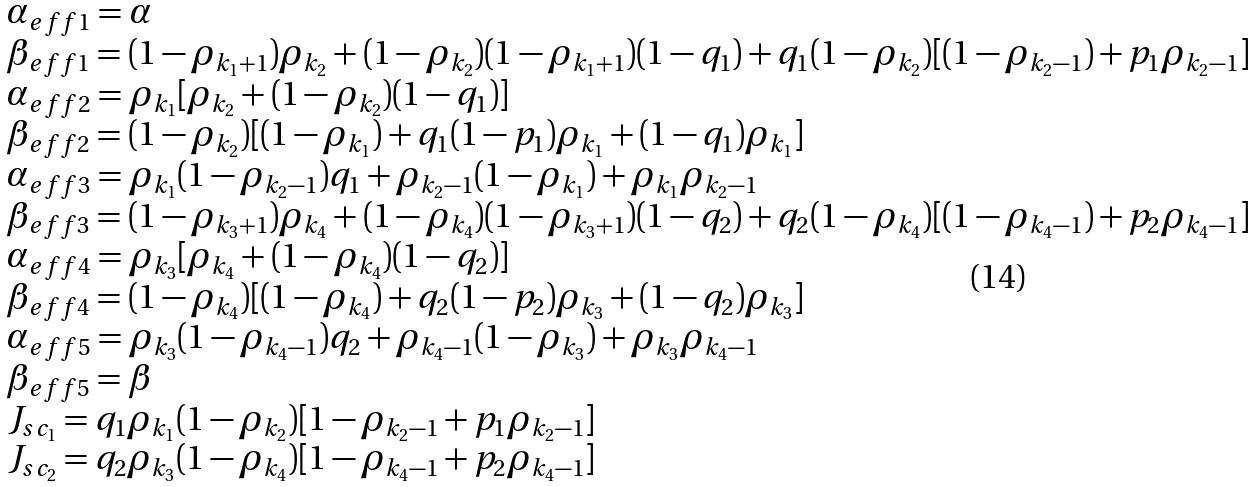Convert formula to latex. <formula><loc_0><loc_0><loc_500><loc_500>\begin{array} { l } \alpha _ { e f f 1 } = \alpha \\ \beta _ { e f f 1 } = ( 1 - \rho _ { k _ { 1 } + 1 } ) \rho _ { k _ { 2 } } + ( 1 - \rho _ { k _ { 2 } } ) ( 1 - \rho _ { k _ { 1 } + 1 } ) ( 1 - q _ { 1 } ) + q _ { 1 } ( 1 - \rho _ { k _ { 2 } } ) [ ( 1 - \rho _ { k _ { 2 } - 1 } ) + p _ { 1 } \rho _ { k _ { 2 } - 1 } ] \\ \alpha _ { e f f 2 } = \rho _ { k _ { 1 } } [ \rho _ { k _ { 2 } } + ( 1 - \rho _ { k _ { 2 } } ) ( 1 - q _ { 1 } ) ] \\ \beta _ { e f f 2 } = ( 1 - \rho _ { k _ { 2 } } ) [ ( 1 - \rho _ { k _ { 1 } } ) + q _ { 1 } ( 1 - p _ { 1 } ) \rho _ { k _ { 1 } } + ( 1 - q _ { 1 } ) \rho _ { k _ { 1 } } ] \\ \alpha _ { e f f 3 } = \rho _ { k _ { 1 } } ( 1 - \rho _ { k _ { 2 } - 1 } ) q _ { 1 } + \rho _ { k _ { 2 } - 1 } ( 1 - \rho _ { k _ { 1 } } ) + \rho _ { k _ { 1 } } \rho _ { k _ { 2 } - 1 } \\ \beta _ { e f f 3 } = ( 1 - \rho _ { k _ { 3 } + 1 } ) \rho _ { k _ { 4 } } + ( 1 - \rho _ { k _ { 4 } } ) ( 1 - \rho _ { k _ { 3 } + 1 } ) ( 1 - q _ { 2 } ) + q _ { 2 } ( 1 - \rho _ { k _ { 4 } } ) [ ( 1 - \rho _ { k _ { 4 } - 1 } ) + p _ { 2 } \rho _ { k _ { 4 } - 1 } ] \\ \alpha _ { e f f 4 } = \rho _ { k _ { 3 } } [ \rho _ { k _ { 4 } } + ( 1 - \rho _ { k _ { 4 } } ) ( 1 - q _ { 2 } ) ] \\ \beta _ { e f f 4 } = ( 1 - \rho _ { k _ { 4 } } ) [ ( 1 - \rho _ { k _ { 4 } } ) + q _ { 2 } ( 1 - p _ { 2 } ) \rho _ { k _ { 3 } } + ( 1 - q _ { 2 } ) \rho _ { k _ { 3 } } ] \\ \alpha _ { e f f 5 } = \rho _ { k _ { 3 } } ( 1 - \rho _ { k _ { 4 } - 1 } ) q _ { 2 } + \rho _ { k _ { 4 } - 1 } ( 1 - \rho _ { k _ { 3 } } ) + \rho _ { k _ { 3 } } \rho _ { k _ { 4 } - 1 } \\ \beta _ { e f f 5 } = \beta \\ J _ { s c _ { 1 } } = q _ { 1 } \rho _ { k _ { 1 } } ( 1 - \rho _ { k _ { 2 } } ) [ 1 - \rho _ { k _ { 2 } - 1 } + p _ { 1 } \rho _ { k _ { 2 } - 1 } ] \\ J _ { s c _ { 2 } } = q _ { 2 } \rho _ { k _ { 3 } } ( 1 - \rho _ { k _ { 4 } } ) [ 1 - \rho _ { k _ { 4 } - 1 } + p _ { 2 } \rho _ { k _ { 4 } - 1 } ] \\ \end{array}</formula> 